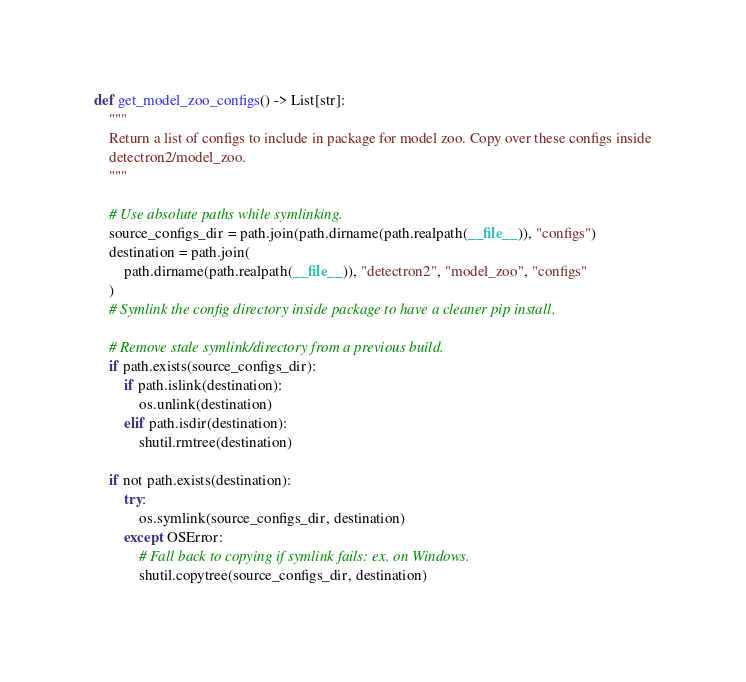Convert code to text. <code><loc_0><loc_0><loc_500><loc_500><_Python_>

def get_model_zoo_configs() -> List[str]:
    """
    Return a list of configs to include in package for model zoo. Copy over these configs inside
    detectron2/model_zoo.
    """

    # Use absolute paths while symlinking.
    source_configs_dir = path.join(path.dirname(path.realpath(__file__)), "configs")
    destination = path.join(
        path.dirname(path.realpath(__file__)), "detectron2", "model_zoo", "configs"
    )
    # Symlink the config directory inside package to have a cleaner pip install.

    # Remove stale symlink/directory from a previous build.
    if path.exists(source_configs_dir):
        if path.islink(destination):
            os.unlink(destination)
        elif path.isdir(destination):
            shutil.rmtree(destination)

    if not path.exists(destination):
        try:
            os.symlink(source_configs_dir, destination)
        except OSError:
            # Fall back to copying if symlink fails: ex. on Windows.
            shutil.copytree(source_configs_dir, destination)
</code> 